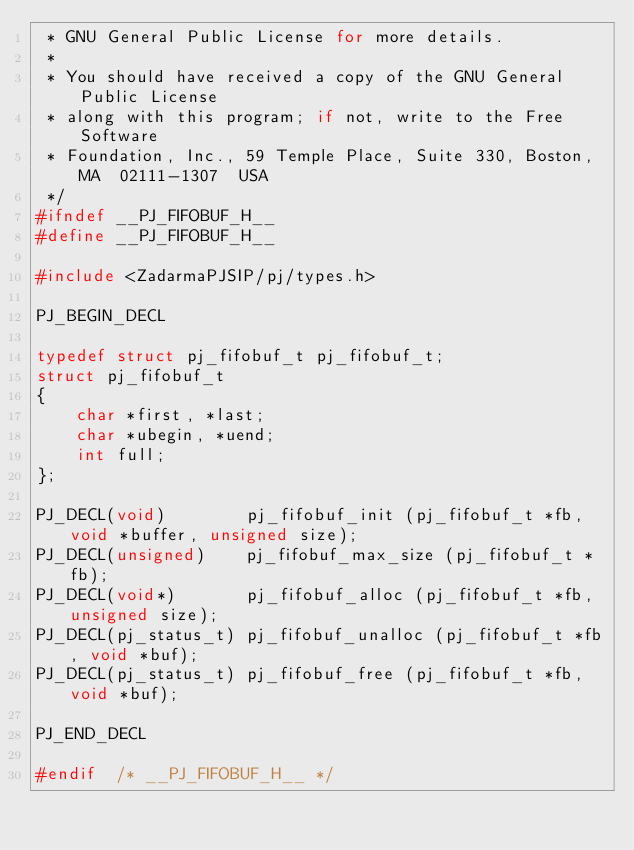<code> <loc_0><loc_0><loc_500><loc_500><_C_> * GNU General Public License for more details.
 *
 * You should have received a copy of the GNU General Public License
 * along with this program; if not, write to the Free Software
 * Foundation, Inc., 59 Temple Place, Suite 330, Boston, MA  02111-1307  USA 
 */
#ifndef __PJ_FIFOBUF_H__
#define __PJ_FIFOBUF_H__

#include <ZadarmaPJSIP/pj/types.h>

PJ_BEGIN_DECL

typedef struct pj_fifobuf_t pj_fifobuf_t;
struct pj_fifobuf_t
{
    char *first, *last;
    char *ubegin, *uend;
    int full;
};

PJ_DECL(void)	     pj_fifobuf_init (pj_fifobuf_t *fb, void *buffer, unsigned size);
PJ_DECL(unsigned)    pj_fifobuf_max_size (pj_fifobuf_t *fb);
PJ_DECL(void*)	     pj_fifobuf_alloc (pj_fifobuf_t *fb, unsigned size);
PJ_DECL(pj_status_t) pj_fifobuf_unalloc (pj_fifobuf_t *fb, void *buf);
PJ_DECL(pj_status_t) pj_fifobuf_free (pj_fifobuf_t *fb, void *buf);

PJ_END_DECL

#endif	/* __PJ_FIFOBUF_H__ */

</code> 